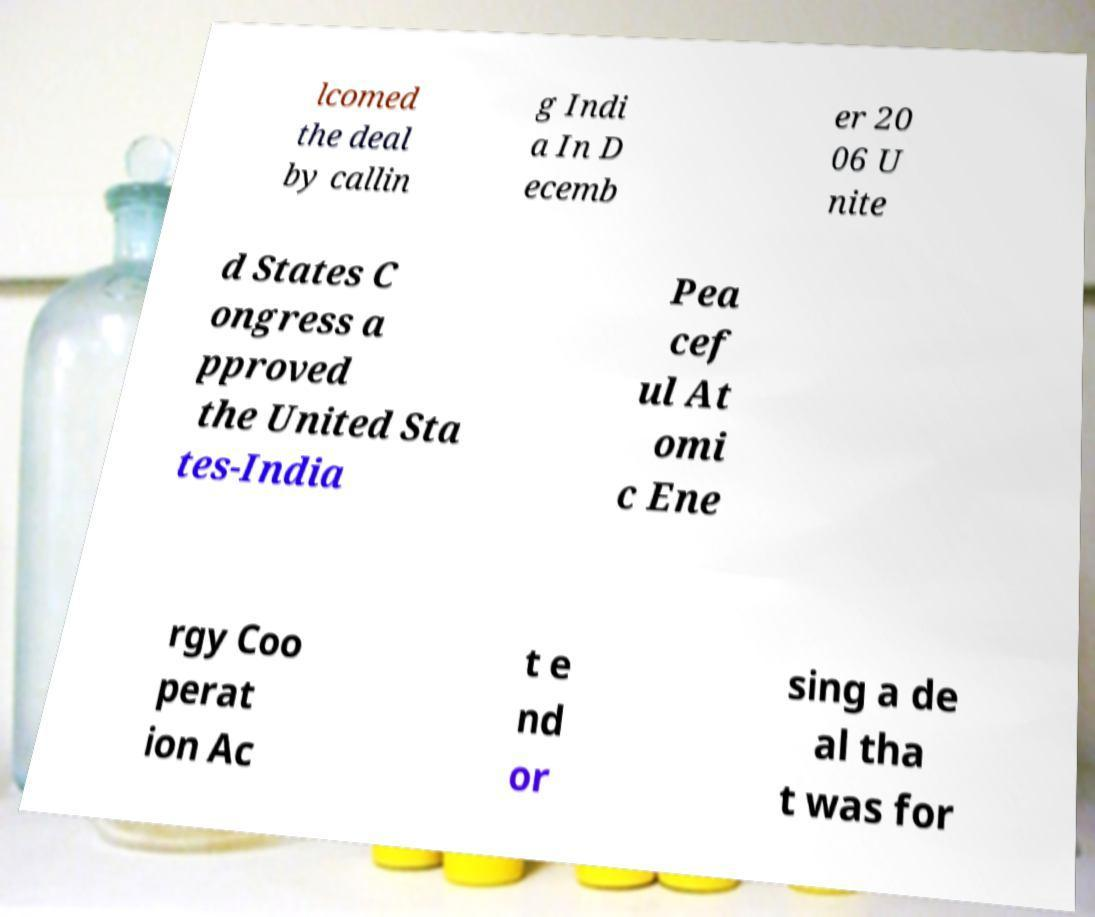What messages or text are displayed in this image? I need them in a readable, typed format. lcomed the deal by callin g Indi a In D ecemb er 20 06 U nite d States C ongress a pproved the United Sta tes-India Pea cef ul At omi c Ene rgy Coo perat ion Ac t e nd or sing a de al tha t was for 